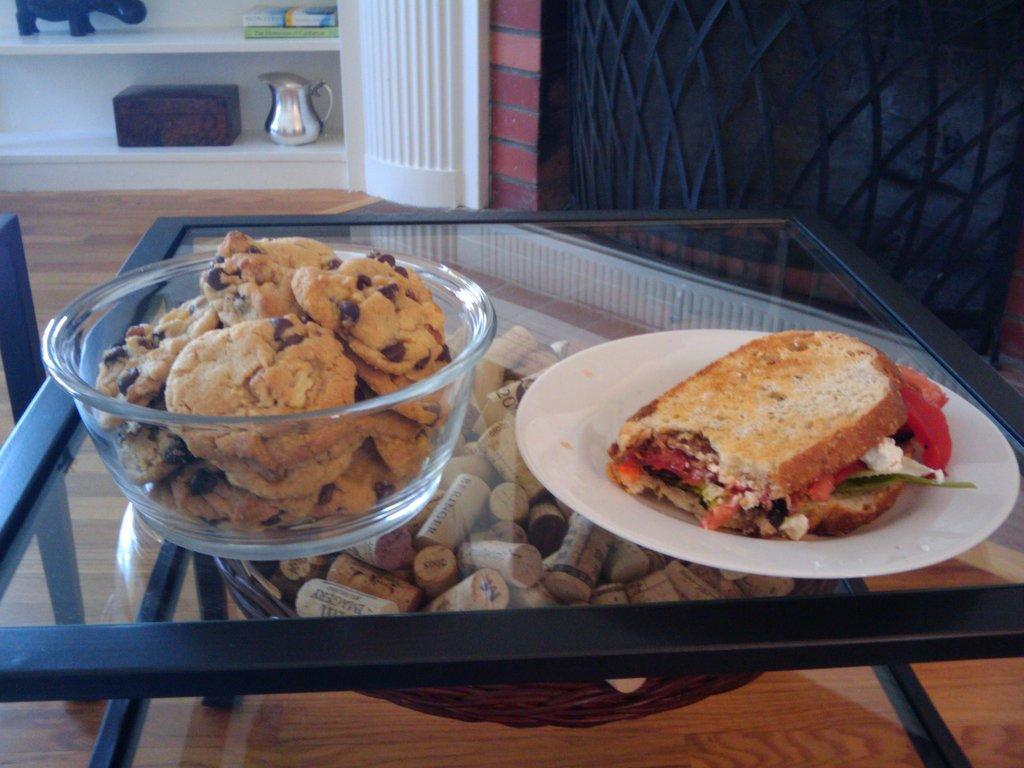Please provide a concise description of this image. In the foreground of this image, there is a table on which cookies in a bowl and sandwich in a plate is placed. In the background, there are jar, box, books and a toy in the shelf. 